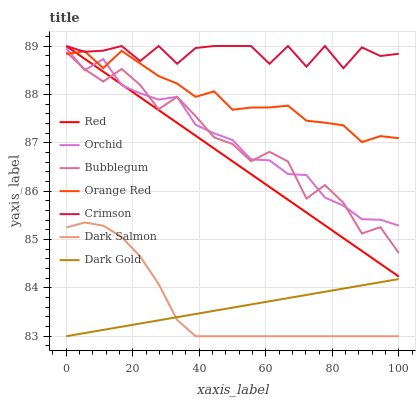Does Dark Gold have the minimum area under the curve?
Answer yes or no. Yes. Does Crimson have the maximum area under the curve?
Answer yes or no. Yes. Does Dark Salmon have the minimum area under the curve?
Answer yes or no. No. Does Dark Salmon have the maximum area under the curve?
Answer yes or no. No. Is Dark Gold the smoothest?
Answer yes or no. Yes. Is Crimson the roughest?
Answer yes or no. Yes. Is Dark Salmon the smoothest?
Answer yes or no. No. Is Dark Salmon the roughest?
Answer yes or no. No. Does Dark Gold have the lowest value?
Answer yes or no. Yes. Does Bubblegum have the lowest value?
Answer yes or no. No. Does Red have the highest value?
Answer yes or no. Yes. Does Dark Salmon have the highest value?
Answer yes or no. No. Is Dark Gold less than Orchid?
Answer yes or no. Yes. Is Red greater than Dark Gold?
Answer yes or no. Yes. Does Crimson intersect Red?
Answer yes or no. Yes. Is Crimson less than Red?
Answer yes or no. No. Is Crimson greater than Red?
Answer yes or no. No. Does Dark Gold intersect Orchid?
Answer yes or no. No. 